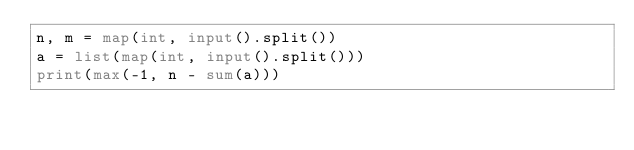Convert code to text. <code><loc_0><loc_0><loc_500><loc_500><_Python_>n, m = map(int, input().split())
a = list(map(int, input().split()))
print(max(-1, n - sum(a)))
</code> 